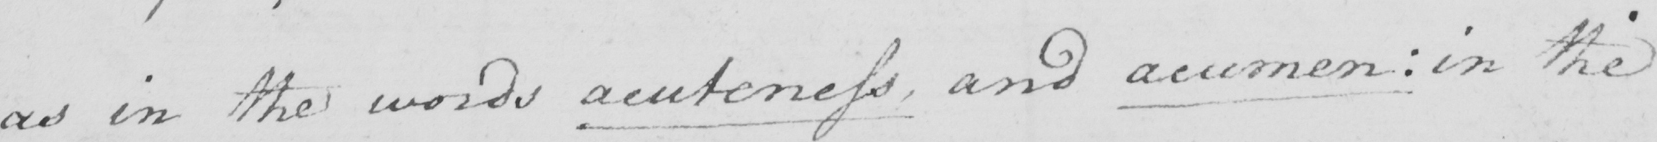What does this handwritten line say? as in the words acuteness , and acumen :  in the 